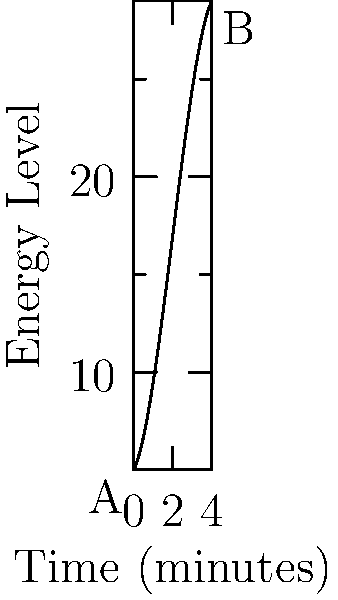During your nephew's basketball game, you notice the team's energy levels fluctuate. A coach measures this using a polynomial function $f(x) = -0.5x^3 + 3x^2 + 2x + 5$, where $x$ is the time in minutes and $f(x)$ represents the team's energy level. What is the total energy expended by the team during the first 4 minutes of the game, represented by the area under the curve from point A to point B? To find the area under the curve, we need to integrate the function from 0 to 4 minutes:

1) The integral is: 
   $$\int_0^4 (-0.5x^3 + 3x^2 + 2x + 5) dx$$

2) Integrate each term:
   $$[-\frac{1}{8}x^4 + x^3 + x^2 + 5x]_0^4$$

3) Evaluate at the upper limit (x = 4):
   $$(-\frac{1}{8}(4^4) + (4^3) + (4^2) + 5(4)) = (-16 + 64 + 16 + 20) = 84$$

4) Evaluate at the lower limit (x = 0):
   $$(-\frac{1}{8}(0^4) + (0^3) + (0^2) + 5(0)) = 0$$

5) Subtract the lower limit from the upper limit:
   $$84 - 0 = 84$$

Therefore, the total energy expended (area under the curve) is 84 energy units.
Answer: 84 energy units 